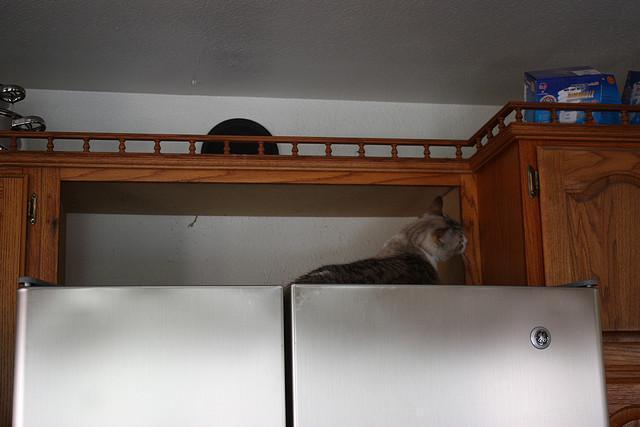How many refrigerators are in the photo?
Give a very brief answer. 2. How many people are wearing green shirt?
Give a very brief answer. 0. 